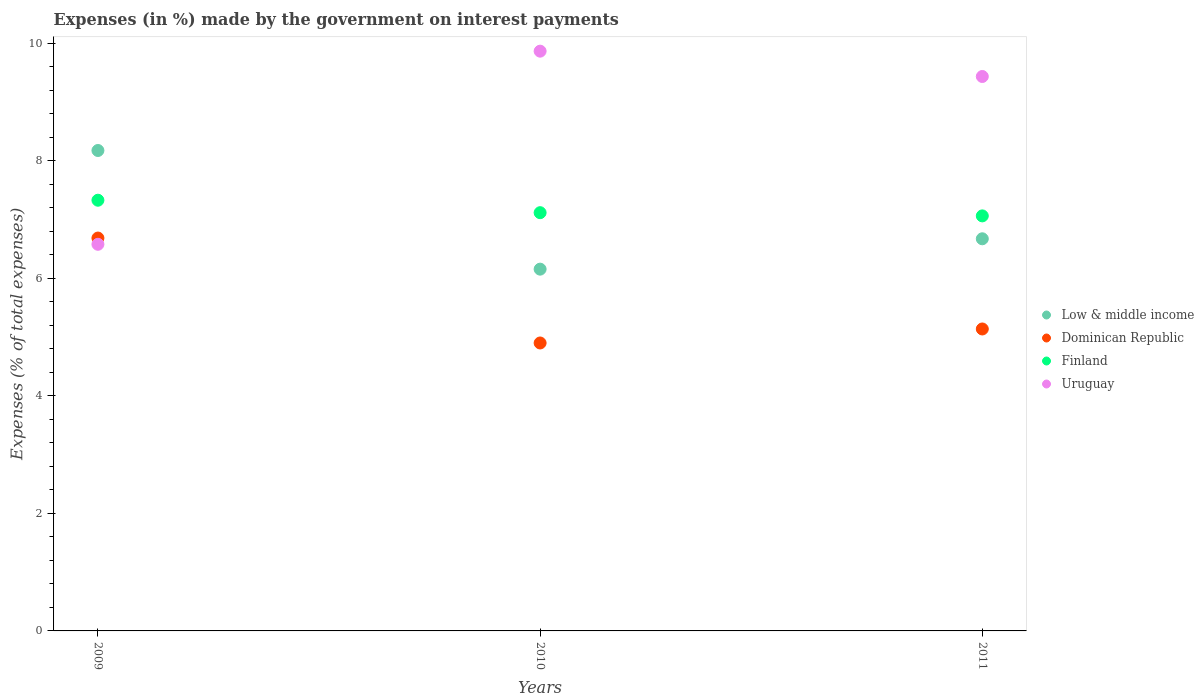How many different coloured dotlines are there?
Give a very brief answer. 4. Is the number of dotlines equal to the number of legend labels?
Offer a terse response. Yes. What is the percentage of expenses made by the government on interest payments in Dominican Republic in 2009?
Provide a succinct answer. 6.68. Across all years, what is the maximum percentage of expenses made by the government on interest payments in Finland?
Your answer should be very brief. 7.33. Across all years, what is the minimum percentage of expenses made by the government on interest payments in Dominican Republic?
Your answer should be compact. 4.9. In which year was the percentage of expenses made by the government on interest payments in Uruguay maximum?
Provide a short and direct response. 2010. What is the total percentage of expenses made by the government on interest payments in Uruguay in the graph?
Your answer should be very brief. 25.87. What is the difference between the percentage of expenses made by the government on interest payments in Finland in 2009 and that in 2011?
Provide a short and direct response. 0.27. What is the difference between the percentage of expenses made by the government on interest payments in Finland in 2011 and the percentage of expenses made by the government on interest payments in Uruguay in 2009?
Give a very brief answer. 0.48. What is the average percentage of expenses made by the government on interest payments in Dominican Republic per year?
Offer a very short reply. 5.57. In the year 2010, what is the difference between the percentage of expenses made by the government on interest payments in Finland and percentage of expenses made by the government on interest payments in Uruguay?
Offer a terse response. -2.75. What is the ratio of the percentage of expenses made by the government on interest payments in Uruguay in 2009 to that in 2011?
Make the answer very short. 0.7. What is the difference between the highest and the second highest percentage of expenses made by the government on interest payments in Dominican Republic?
Keep it short and to the point. 1.55. What is the difference between the highest and the lowest percentage of expenses made by the government on interest payments in Finland?
Give a very brief answer. 0.27. In how many years, is the percentage of expenses made by the government on interest payments in Uruguay greater than the average percentage of expenses made by the government on interest payments in Uruguay taken over all years?
Your answer should be very brief. 2. Is it the case that in every year, the sum of the percentage of expenses made by the government on interest payments in Dominican Republic and percentage of expenses made by the government on interest payments in Low & middle income  is greater than the sum of percentage of expenses made by the government on interest payments in Uruguay and percentage of expenses made by the government on interest payments in Finland?
Provide a short and direct response. No. Does the percentage of expenses made by the government on interest payments in Low & middle income monotonically increase over the years?
Ensure brevity in your answer.  No. Is the percentage of expenses made by the government on interest payments in Finland strictly greater than the percentage of expenses made by the government on interest payments in Low & middle income over the years?
Offer a terse response. No. How many dotlines are there?
Provide a succinct answer. 4. What is the difference between two consecutive major ticks on the Y-axis?
Provide a short and direct response. 2. Are the values on the major ticks of Y-axis written in scientific E-notation?
Your response must be concise. No. Does the graph contain any zero values?
Provide a succinct answer. No. Does the graph contain grids?
Provide a succinct answer. No. How are the legend labels stacked?
Offer a terse response. Vertical. What is the title of the graph?
Offer a very short reply. Expenses (in %) made by the government on interest payments. Does "Paraguay" appear as one of the legend labels in the graph?
Keep it short and to the point. No. What is the label or title of the Y-axis?
Your answer should be very brief. Expenses (% of total expenses). What is the Expenses (% of total expenses) of Low & middle income in 2009?
Provide a short and direct response. 8.17. What is the Expenses (% of total expenses) of Dominican Republic in 2009?
Offer a very short reply. 6.68. What is the Expenses (% of total expenses) of Finland in 2009?
Provide a short and direct response. 7.33. What is the Expenses (% of total expenses) in Uruguay in 2009?
Ensure brevity in your answer.  6.58. What is the Expenses (% of total expenses) of Low & middle income in 2010?
Your response must be concise. 6.15. What is the Expenses (% of total expenses) in Dominican Republic in 2010?
Make the answer very short. 4.9. What is the Expenses (% of total expenses) of Finland in 2010?
Keep it short and to the point. 7.11. What is the Expenses (% of total expenses) in Uruguay in 2010?
Provide a succinct answer. 9.86. What is the Expenses (% of total expenses) of Low & middle income in 2011?
Keep it short and to the point. 6.67. What is the Expenses (% of total expenses) in Dominican Republic in 2011?
Your response must be concise. 5.14. What is the Expenses (% of total expenses) in Finland in 2011?
Provide a short and direct response. 7.06. What is the Expenses (% of total expenses) of Uruguay in 2011?
Offer a terse response. 9.43. Across all years, what is the maximum Expenses (% of total expenses) in Low & middle income?
Offer a terse response. 8.17. Across all years, what is the maximum Expenses (% of total expenses) in Dominican Republic?
Provide a succinct answer. 6.68. Across all years, what is the maximum Expenses (% of total expenses) in Finland?
Your answer should be compact. 7.33. Across all years, what is the maximum Expenses (% of total expenses) in Uruguay?
Provide a short and direct response. 9.86. Across all years, what is the minimum Expenses (% of total expenses) in Low & middle income?
Keep it short and to the point. 6.15. Across all years, what is the minimum Expenses (% of total expenses) in Dominican Republic?
Make the answer very short. 4.9. Across all years, what is the minimum Expenses (% of total expenses) in Finland?
Provide a succinct answer. 7.06. Across all years, what is the minimum Expenses (% of total expenses) of Uruguay?
Provide a succinct answer. 6.58. What is the total Expenses (% of total expenses) in Low & middle income in the graph?
Provide a short and direct response. 21. What is the total Expenses (% of total expenses) of Dominican Republic in the graph?
Provide a succinct answer. 16.72. What is the total Expenses (% of total expenses) in Finland in the graph?
Provide a short and direct response. 21.5. What is the total Expenses (% of total expenses) in Uruguay in the graph?
Your answer should be compact. 25.87. What is the difference between the Expenses (% of total expenses) in Low & middle income in 2009 and that in 2010?
Offer a terse response. 2.02. What is the difference between the Expenses (% of total expenses) of Dominican Republic in 2009 and that in 2010?
Offer a terse response. 1.78. What is the difference between the Expenses (% of total expenses) of Finland in 2009 and that in 2010?
Offer a very short reply. 0.21. What is the difference between the Expenses (% of total expenses) of Uruguay in 2009 and that in 2010?
Ensure brevity in your answer.  -3.29. What is the difference between the Expenses (% of total expenses) in Low & middle income in 2009 and that in 2011?
Offer a terse response. 1.5. What is the difference between the Expenses (% of total expenses) of Dominican Republic in 2009 and that in 2011?
Make the answer very short. 1.55. What is the difference between the Expenses (% of total expenses) of Finland in 2009 and that in 2011?
Offer a very short reply. 0.27. What is the difference between the Expenses (% of total expenses) of Uruguay in 2009 and that in 2011?
Your answer should be very brief. -2.85. What is the difference between the Expenses (% of total expenses) in Low & middle income in 2010 and that in 2011?
Keep it short and to the point. -0.52. What is the difference between the Expenses (% of total expenses) in Dominican Republic in 2010 and that in 2011?
Give a very brief answer. -0.24. What is the difference between the Expenses (% of total expenses) of Finland in 2010 and that in 2011?
Give a very brief answer. 0.05. What is the difference between the Expenses (% of total expenses) in Uruguay in 2010 and that in 2011?
Provide a succinct answer. 0.43. What is the difference between the Expenses (% of total expenses) in Low & middle income in 2009 and the Expenses (% of total expenses) in Dominican Republic in 2010?
Keep it short and to the point. 3.27. What is the difference between the Expenses (% of total expenses) of Low & middle income in 2009 and the Expenses (% of total expenses) of Finland in 2010?
Give a very brief answer. 1.06. What is the difference between the Expenses (% of total expenses) in Low & middle income in 2009 and the Expenses (% of total expenses) in Uruguay in 2010?
Offer a terse response. -1.69. What is the difference between the Expenses (% of total expenses) in Dominican Republic in 2009 and the Expenses (% of total expenses) in Finland in 2010?
Your answer should be very brief. -0.43. What is the difference between the Expenses (% of total expenses) of Dominican Republic in 2009 and the Expenses (% of total expenses) of Uruguay in 2010?
Provide a succinct answer. -3.18. What is the difference between the Expenses (% of total expenses) in Finland in 2009 and the Expenses (% of total expenses) in Uruguay in 2010?
Offer a very short reply. -2.54. What is the difference between the Expenses (% of total expenses) of Low & middle income in 2009 and the Expenses (% of total expenses) of Dominican Republic in 2011?
Make the answer very short. 3.04. What is the difference between the Expenses (% of total expenses) in Low & middle income in 2009 and the Expenses (% of total expenses) in Finland in 2011?
Your answer should be very brief. 1.11. What is the difference between the Expenses (% of total expenses) in Low & middle income in 2009 and the Expenses (% of total expenses) in Uruguay in 2011?
Offer a terse response. -1.26. What is the difference between the Expenses (% of total expenses) in Dominican Republic in 2009 and the Expenses (% of total expenses) in Finland in 2011?
Ensure brevity in your answer.  -0.38. What is the difference between the Expenses (% of total expenses) of Dominican Republic in 2009 and the Expenses (% of total expenses) of Uruguay in 2011?
Provide a succinct answer. -2.75. What is the difference between the Expenses (% of total expenses) in Finland in 2009 and the Expenses (% of total expenses) in Uruguay in 2011?
Offer a very short reply. -2.1. What is the difference between the Expenses (% of total expenses) in Low & middle income in 2010 and the Expenses (% of total expenses) in Dominican Republic in 2011?
Ensure brevity in your answer.  1.02. What is the difference between the Expenses (% of total expenses) of Low & middle income in 2010 and the Expenses (% of total expenses) of Finland in 2011?
Your answer should be very brief. -0.91. What is the difference between the Expenses (% of total expenses) of Low & middle income in 2010 and the Expenses (% of total expenses) of Uruguay in 2011?
Keep it short and to the point. -3.28. What is the difference between the Expenses (% of total expenses) in Dominican Republic in 2010 and the Expenses (% of total expenses) in Finland in 2011?
Your answer should be very brief. -2.16. What is the difference between the Expenses (% of total expenses) of Dominican Republic in 2010 and the Expenses (% of total expenses) of Uruguay in 2011?
Offer a terse response. -4.53. What is the difference between the Expenses (% of total expenses) in Finland in 2010 and the Expenses (% of total expenses) in Uruguay in 2011?
Make the answer very short. -2.32. What is the average Expenses (% of total expenses) in Low & middle income per year?
Provide a succinct answer. 7. What is the average Expenses (% of total expenses) of Dominican Republic per year?
Offer a terse response. 5.57. What is the average Expenses (% of total expenses) in Finland per year?
Provide a short and direct response. 7.17. What is the average Expenses (% of total expenses) of Uruguay per year?
Ensure brevity in your answer.  8.62. In the year 2009, what is the difference between the Expenses (% of total expenses) of Low & middle income and Expenses (% of total expenses) of Dominican Republic?
Offer a very short reply. 1.49. In the year 2009, what is the difference between the Expenses (% of total expenses) in Low & middle income and Expenses (% of total expenses) in Finland?
Your answer should be very brief. 0.85. In the year 2009, what is the difference between the Expenses (% of total expenses) of Low & middle income and Expenses (% of total expenses) of Uruguay?
Provide a succinct answer. 1.6. In the year 2009, what is the difference between the Expenses (% of total expenses) of Dominican Republic and Expenses (% of total expenses) of Finland?
Ensure brevity in your answer.  -0.64. In the year 2009, what is the difference between the Expenses (% of total expenses) of Dominican Republic and Expenses (% of total expenses) of Uruguay?
Your response must be concise. 0.11. In the year 2009, what is the difference between the Expenses (% of total expenses) in Finland and Expenses (% of total expenses) in Uruguay?
Offer a very short reply. 0.75. In the year 2010, what is the difference between the Expenses (% of total expenses) in Low & middle income and Expenses (% of total expenses) in Dominican Republic?
Give a very brief answer. 1.26. In the year 2010, what is the difference between the Expenses (% of total expenses) in Low & middle income and Expenses (% of total expenses) in Finland?
Offer a terse response. -0.96. In the year 2010, what is the difference between the Expenses (% of total expenses) of Low & middle income and Expenses (% of total expenses) of Uruguay?
Your response must be concise. -3.71. In the year 2010, what is the difference between the Expenses (% of total expenses) of Dominican Republic and Expenses (% of total expenses) of Finland?
Keep it short and to the point. -2.22. In the year 2010, what is the difference between the Expenses (% of total expenses) in Dominican Republic and Expenses (% of total expenses) in Uruguay?
Ensure brevity in your answer.  -4.96. In the year 2010, what is the difference between the Expenses (% of total expenses) in Finland and Expenses (% of total expenses) in Uruguay?
Your answer should be very brief. -2.75. In the year 2011, what is the difference between the Expenses (% of total expenses) in Low & middle income and Expenses (% of total expenses) in Dominican Republic?
Your response must be concise. 1.53. In the year 2011, what is the difference between the Expenses (% of total expenses) in Low & middle income and Expenses (% of total expenses) in Finland?
Give a very brief answer. -0.39. In the year 2011, what is the difference between the Expenses (% of total expenses) of Low & middle income and Expenses (% of total expenses) of Uruguay?
Offer a terse response. -2.76. In the year 2011, what is the difference between the Expenses (% of total expenses) in Dominican Republic and Expenses (% of total expenses) in Finland?
Give a very brief answer. -1.92. In the year 2011, what is the difference between the Expenses (% of total expenses) of Dominican Republic and Expenses (% of total expenses) of Uruguay?
Your answer should be compact. -4.29. In the year 2011, what is the difference between the Expenses (% of total expenses) in Finland and Expenses (% of total expenses) in Uruguay?
Make the answer very short. -2.37. What is the ratio of the Expenses (% of total expenses) of Low & middle income in 2009 to that in 2010?
Offer a very short reply. 1.33. What is the ratio of the Expenses (% of total expenses) in Dominican Republic in 2009 to that in 2010?
Keep it short and to the point. 1.36. What is the ratio of the Expenses (% of total expenses) of Finland in 2009 to that in 2010?
Your answer should be compact. 1.03. What is the ratio of the Expenses (% of total expenses) in Uruguay in 2009 to that in 2010?
Provide a succinct answer. 0.67. What is the ratio of the Expenses (% of total expenses) in Low & middle income in 2009 to that in 2011?
Give a very brief answer. 1.23. What is the ratio of the Expenses (% of total expenses) of Dominican Republic in 2009 to that in 2011?
Your response must be concise. 1.3. What is the ratio of the Expenses (% of total expenses) of Finland in 2009 to that in 2011?
Offer a terse response. 1.04. What is the ratio of the Expenses (% of total expenses) in Uruguay in 2009 to that in 2011?
Offer a very short reply. 0.7. What is the ratio of the Expenses (% of total expenses) in Low & middle income in 2010 to that in 2011?
Give a very brief answer. 0.92. What is the ratio of the Expenses (% of total expenses) of Dominican Republic in 2010 to that in 2011?
Keep it short and to the point. 0.95. What is the ratio of the Expenses (% of total expenses) in Finland in 2010 to that in 2011?
Keep it short and to the point. 1.01. What is the ratio of the Expenses (% of total expenses) of Uruguay in 2010 to that in 2011?
Give a very brief answer. 1.05. What is the difference between the highest and the second highest Expenses (% of total expenses) in Low & middle income?
Give a very brief answer. 1.5. What is the difference between the highest and the second highest Expenses (% of total expenses) of Dominican Republic?
Make the answer very short. 1.55. What is the difference between the highest and the second highest Expenses (% of total expenses) of Finland?
Offer a terse response. 0.21. What is the difference between the highest and the second highest Expenses (% of total expenses) in Uruguay?
Offer a terse response. 0.43. What is the difference between the highest and the lowest Expenses (% of total expenses) in Low & middle income?
Your response must be concise. 2.02. What is the difference between the highest and the lowest Expenses (% of total expenses) in Dominican Republic?
Make the answer very short. 1.78. What is the difference between the highest and the lowest Expenses (% of total expenses) in Finland?
Provide a short and direct response. 0.27. What is the difference between the highest and the lowest Expenses (% of total expenses) of Uruguay?
Your response must be concise. 3.29. 